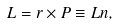Convert formula to latex. <formula><loc_0><loc_0><loc_500><loc_500>L = r \times P \equiv L n ,</formula> 